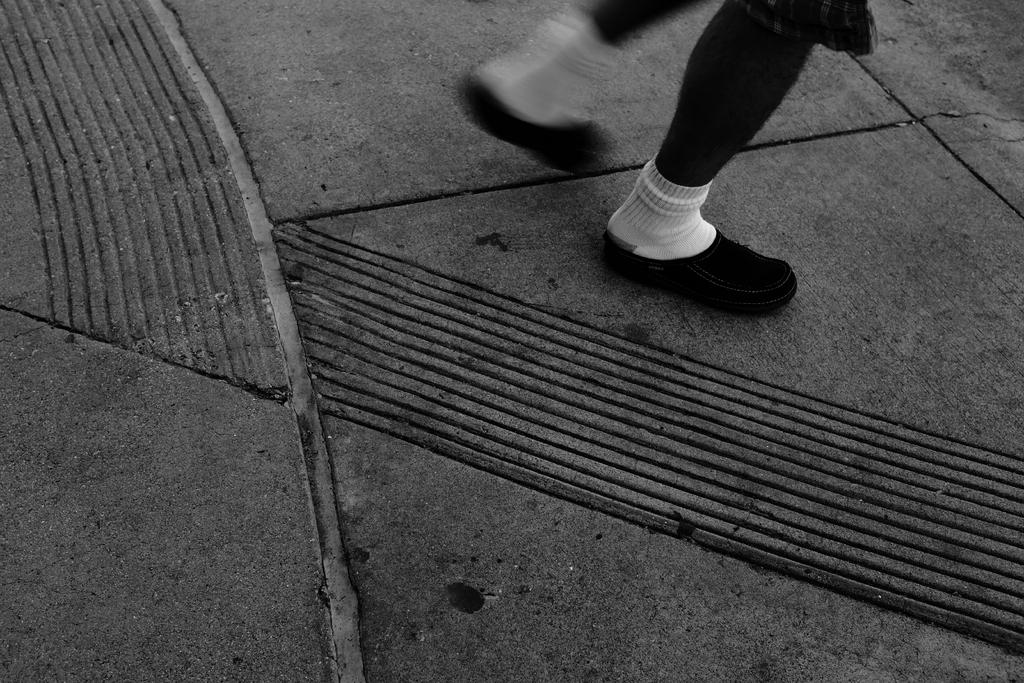What is present in the image? There is a person in the image. What is the person doing in the image? The person is walking on the ground. What part of the person's body is visible on the ground? The person's legs with shoes are visible on the ground. What type of paper is being used by the person in the image? There is no paper present in the image. 